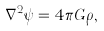Convert formula to latex. <formula><loc_0><loc_0><loc_500><loc_500>\nabla ^ { 2 } \psi = 4 \pi G \rho ,</formula> 